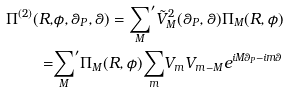Convert formula to latex. <formula><loc_0><loc_0><loc_500><loc_500>\Pi ^ { ( 2 ) } ( R , & \phi , \theta _ { P } , \theta ) = { \sum _ { M } } ^ { \prime } \tilde { V } _ { M } ^ { 2 } ( \theta _ { P } , \theta ) \Pi _ { M } ( R , \phi ) \\ = & { \sum _ { M } } ^ { \prime } \Pi _ { M } ( R , \phi ) { \sum _ { m } } V _ { m } V _ { m - M } e ^ { i M \theta _ { P } - i m \theta }</formula> 